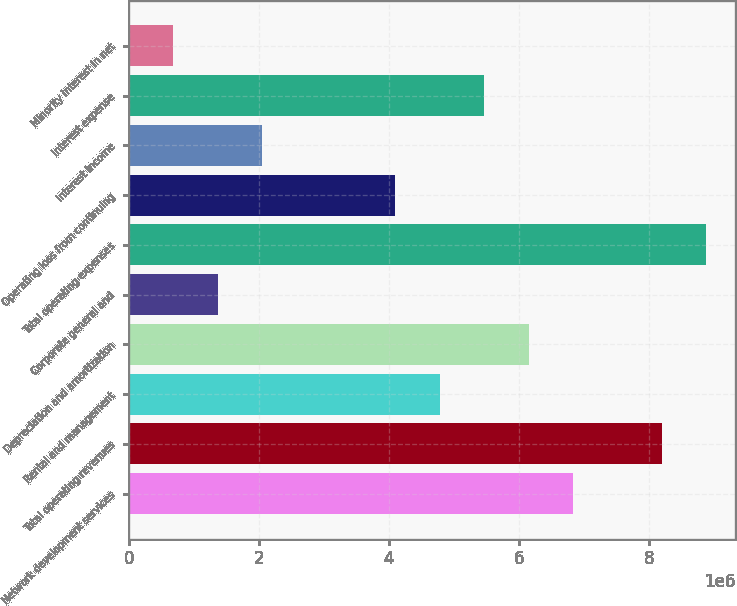<chart> <loc_0><loc_0><loc_500><loc_500><bar_chart><fcel>Network development services<fcel>Total operating revenues<fcel>Rental and management<fcel>Depreciation and amortization<fcel>Corporate general and<fcel>Total operating expenses<fcel>Operating loss from continuing<fcel>Interest income<fcel>Interest expense<fcel>Minority interest in net<nl><fcel>6.82972e+06<fcel>8.19567e+06<fcel>4.78081e+06<fcel>6.14675e+06<fcel>1.36595e+06<fcel>8.87864e+06<fcel>4.09783e+06<fcel>2.04892e+06<fcel>5.46378e+06<fcel>682974<nl></chart> 